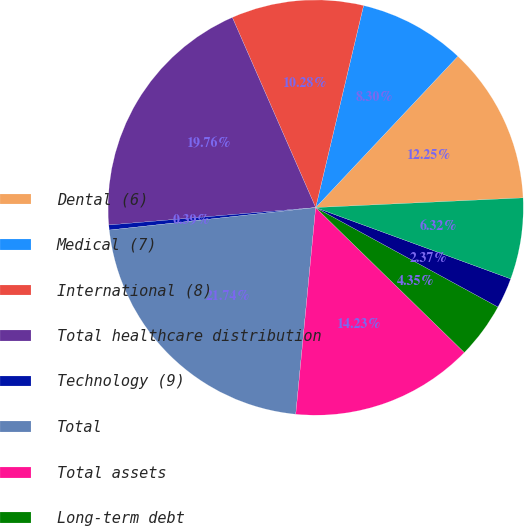Convert chart. <chart><loc_0><loc_0><loc_500><loc_500><pie_chart><fcel>Dental (6)<fcel>Medical (7)<fcel>International (8)<fcel>Total healthcare distribution<fcel>Technology (9)<fcel>Total<fcel>Total assets<fcel>Long-term debt<fcel>Redeemable noncontrolling<fcel>Stockholders' equity<nl><fcel>12.25%<fcel>8.3%<fcel>10.28%<fcel>19.76%<fcel>0.39%<fcel>21.74%<fcel>14.23%<fcel>4.35%<fcel>2.37%<fcel>6.32%<nl></chart> 